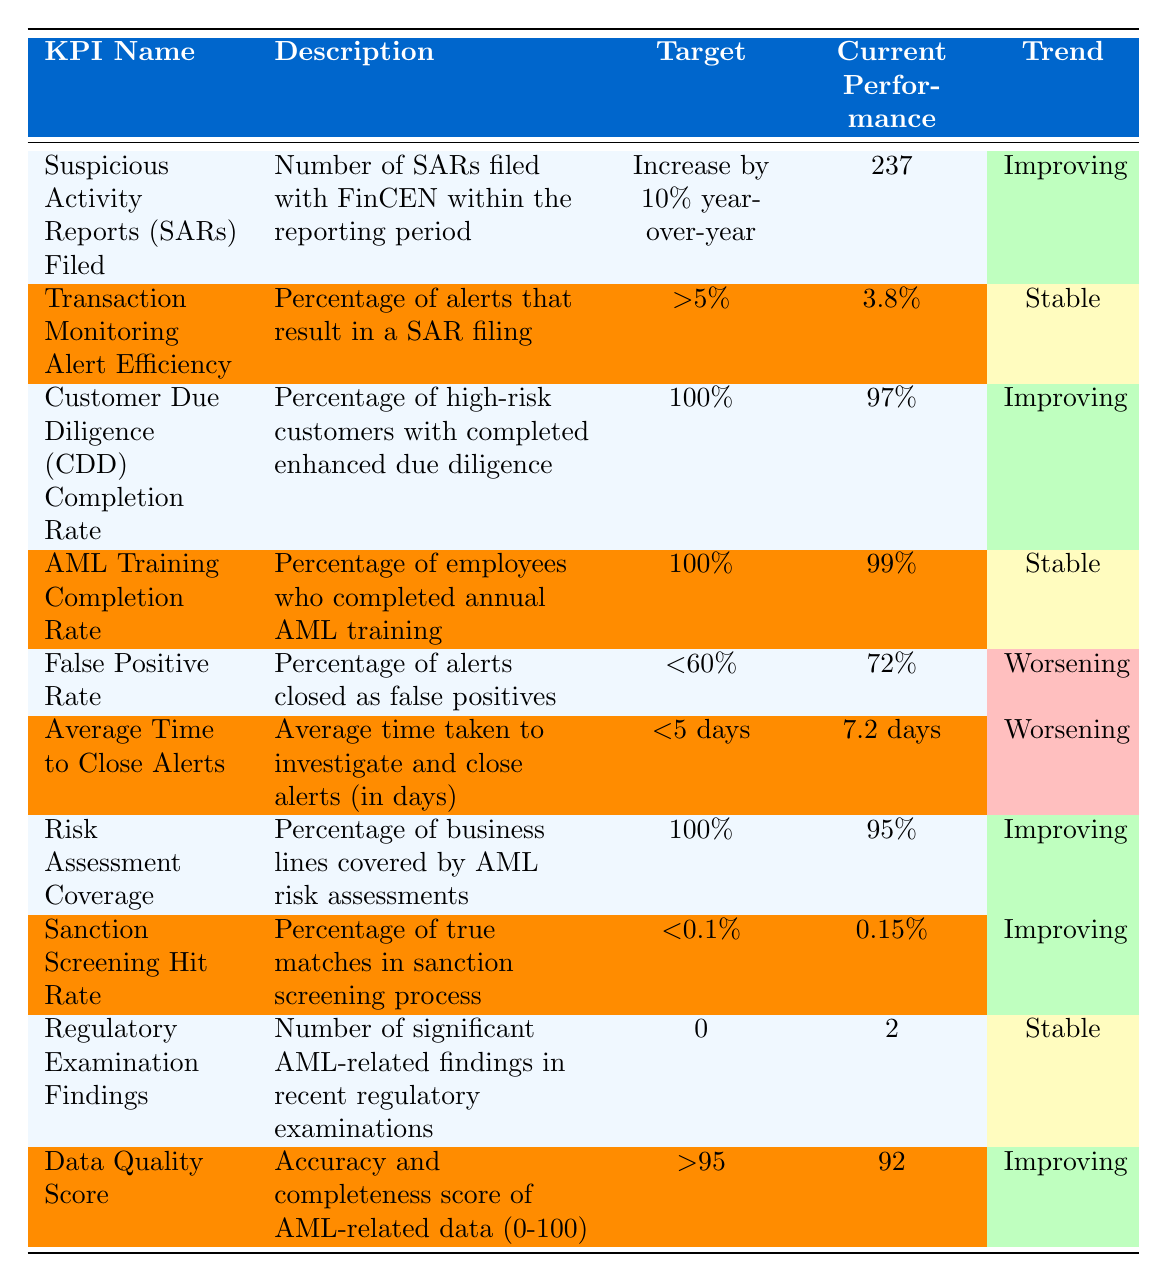What is the target for the Suspicious Activity Reports filed? The target for Suspicious Activity Reports filed is to increase by 10% year-over-year.
Answer: Increase by 10% year-over-year What is the current performance for the AML Training Completion Rate? The current performance for the AML Training Completion Rate is 99%.
Answer: 99% What percentage of alerts are considered false positives? The percentage of alerts closed as false positives is 72%.
Answer: 72% Is the Data Quality Score's current performance above the target? The target for the Data Quality Score is greater than 95, and the current performance is 92, which is below the target.
Answer: No What is the trend for the False Positive Rate? The trend for the False Positive Rate is worsening.
Answer: Worsening How many Regulatory Examination Findings were reported? There were 2 significant AML-related findings in recent regulatory examinations.
Answer: 2 How does the current performance of Transaction Monitoring Alert Efficiency compare to its target? The current performance is 3.8%, and the target is greater than 5%. Thus, the current performance is below the target.
Answer: Below target If the target for Risk Assessment Coverage is 100%, how far are we from achieving it based on current performance? The current performance for Risk Assessment Coverage is 95%, which is 5% below the target of 100%.
Answer: 5% below What is the average of the targets for all KPIs in the table? The targets are a mix of percentages and qualitative statements, so we calculate as follows: (10% + 5% + 100% + 100% + 60% + 5 + 100% + 0.1% + 0 + 95) = 109.1% target value for KPIs that can be averaged. Then, we divide by the number of targetable units (8) which gives us a rough average of 13.64%.
Answer: 13.64% What percentage of current performance is below 100%? The KPIs with current performance below 100% are the Transaction Monitoring Alert Efficiency (3.8%), Customer Due Diligence Completion Rate (97%), False Positive Rate (72%), Average Time to Close Alerts (7.2 days), Sanction Screening Hit Rate (0.15%), and Data Quality Score (92%). There are 6 out of 10 KPIs below 100%.
Answer: 60% 